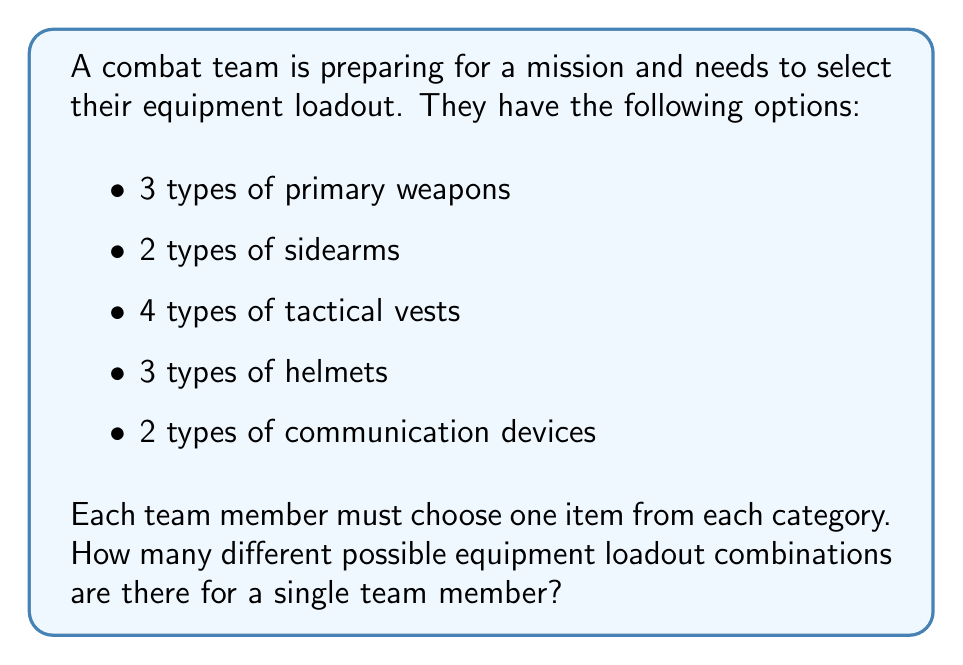Teach me how to tackle this problem. To solve this problem, we need to use the multiplication principle of counting. This principle states that if we have a sequence of choices, and each choice is independent of the others, then the total number of possible outcomes is the product of the number of possibilities for each choice.

Let's break down the choices:

1. Primary weapons: 3 options
2. Sidearms: 2 options
3. Tactical vests: 4 options
4. Helmets: 3 options
5. Communication devices: 2 options

Each of these choices is independent of the others. A team member's choice of primary weapon doesn't affect their choice of sidearm, vest, helmet, or communication device, and so on.

Therefore, we can calculate the total number of possible combinations by multiplying the number of options for each category:

$$ \text{Total combinations} = 3 \times 2 \times 4 \times 3 \times 2 $$

Calculating this:
$$ 3 \times 2 = 6 $$
$$ 6 \times 4 = 24 $$
$$ 24 \times 3 = 72 $$
$$ 72 \times 2 = 144 $$

Thus, there are 144 possible equipment loadout combinations for a single team member.
Answer: 144 possible equipment loadout combinations 